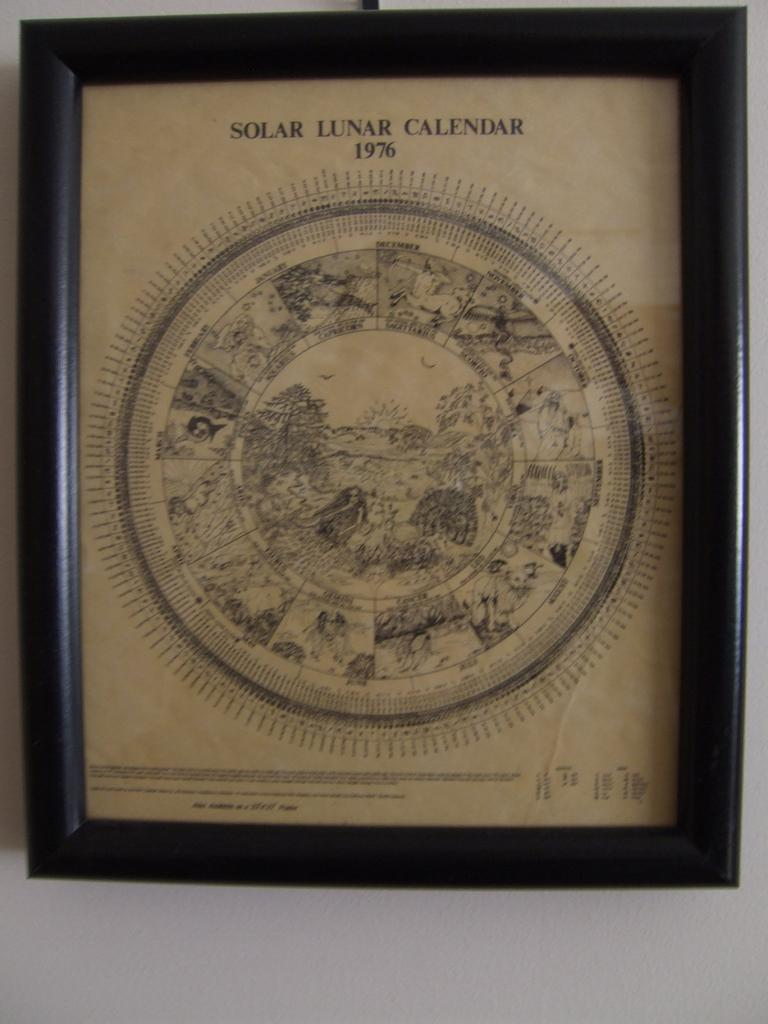<image>
Summarize the visual content of the image. Protected in a black frame is a solar lunar calendar for the year 1976. 